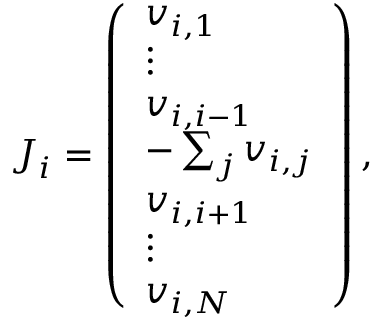Convert formula to latex. <formula><loc_0><loc_0><loc_500><loc_500>\begin{array} { r } { { J } _ { i } = \left ( \begin{array} { l } { { v } _ { i , 1 } } \\ { \vdots } \\ { { v } _ { i , i - 1 } } \\ { - \sum _ { j } { v } _ { i , j } } \\ { { v } _ { i , i + 1 } } \\ { \vdots } \\ { { v } _ { i , N } } \end{array} \right ) , } \end{array}</formula> 